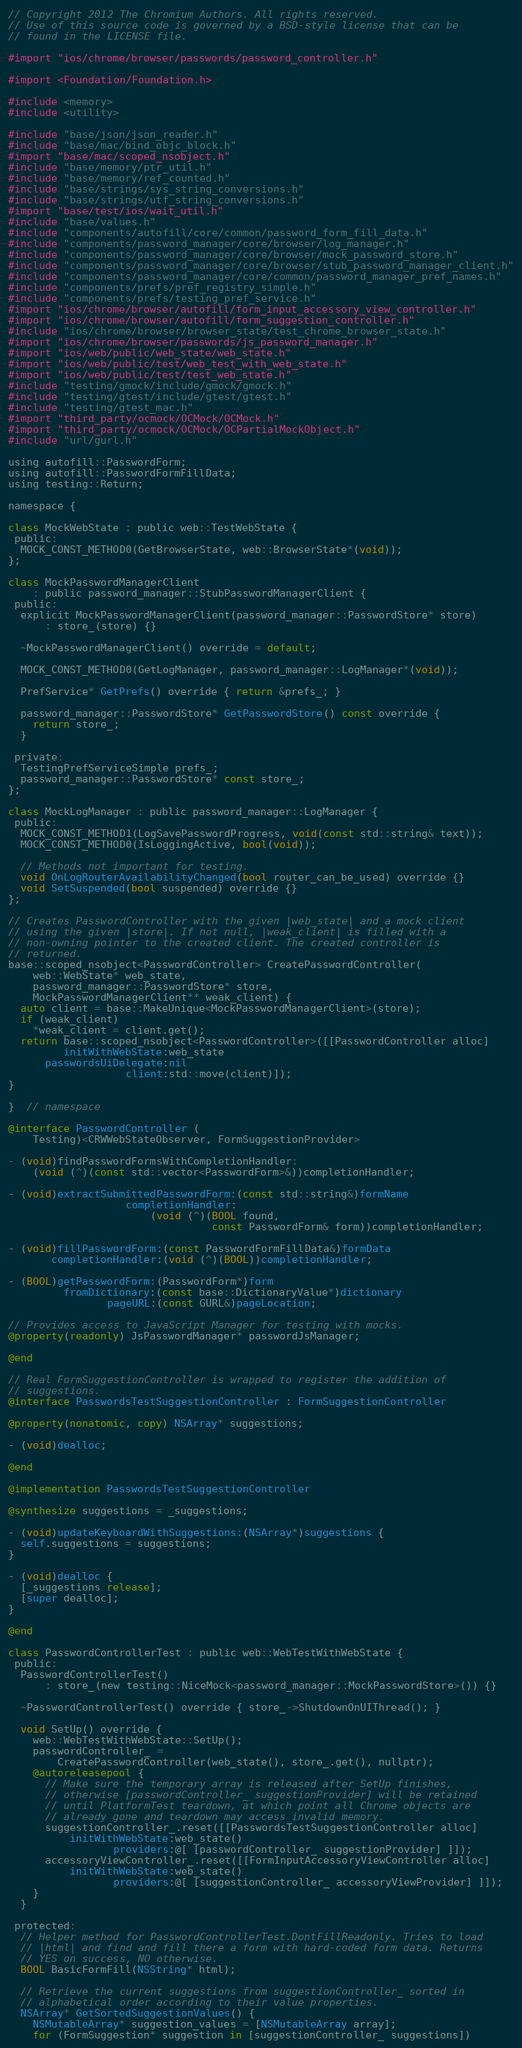Convert code to text. <code><loc_0><loc_0><loc_500><loc_500><_ObjectiveC_>// Copyright 2012 The Chromium Authors. All rights reserved.
// Use of this source code is governed by a BSD-style license that can be
// found in the LICENSE file.

#import "ios/chrome/browser/passwords/password_controller.h"

#import <Foundation/Foundation.h>

#include <memory>
#include <utility>

#include "base/json/json_reader.h"
#include "base/mac/bind_objc_block.h"
#import "base/mac/scoped_nsobject.h"
#include "base/memory/ptr_util.h"
#include "base/memory/ref_counted.h"
#include "base/strings/sys_string_conversions.h"
#include "base/strings/utf_string_conversions.h"
#import "base/test/ios/wait_util.h"
#include "base/values.h"
#include "components/autofill/core/common/password_form_fill_data.h"
#include "components/password_manager/core/browser/log_manager.h"
#include "components/password_manager/core/browser/mock_password_store.h"
#include "components/password_manager/core/browser/stub_password_manager_client.h"
#include "components/password_manager/core/common/password_manager_pref_names.h"
#include "components/prefs/pref_registry_simple.h"
#include "components/prefs/testing_pref_service.h"
#import "ios/chrome/browser/autofill/form_input_accessory_view_controller.h"
#import "ios/chrome/browser/autofill/form_suggestion_controller.h"
#include "ios/chrome/browser/browser_state/test_chrome_browser_state.h"
#import "ios/chrome/browser/passwords/js_password_manager.h"
#import "ios/web/public/web_state/web_state.h"
#import "ios/web/public/test/web_test_with_web_state.h"
#import "ios/web/public/test/test_web_state.h"
#include "testing/gmock/include/gmock/gmock.h"
#include "testing/gtest/include/gtest/gtest.h"
#include "testing/gtest_mac.h"
#import "third_party/ocmock/OCMock/OCMock.h"
#import "third_party/ocmock/OCMock/OCPartialMockObject.h"
#include "url/gurl.h"

using autofill::PasswordForm;
using autofill::PasswordFormFillData;
using testing::Return;

namespace {

class MockWebState : public web::TestWebState {
 public:
  MOCK_CONST_METHOD0(GetBrowserState, web::BrowserState*(void));
};

class MockPasswordManagerClient
    : public password_manager::StubPasswordManagerClient {
 public:
  explicit MockPasswordManagerClient(password_manager::PasswordStore* store)
      : store_(store) {}

  ~MockPasswordManagerClient() override = default;

  MOCK_CONST_METHOD0(GetLogManager, password_manager::LogManager*(void));

  PrefService* GetPrefs() override { return &prefs_; }

  password_manager::PasswordStore* GetPasswordStore() const override {
    return store_;
  }

 private:
  TestingPrefServiceSimple prefs_;
  password_manager::PasswordStore* const store_;
};

class MockLogManager : public password_manager::LogManager {
 public:
  MOCK_CONST_METHOD1(LogSavePasswordProgress, void(const std::string& text));
  MOCK_CONST_METHOD0(IsLoggingActive, bool(void));

  // Methods not important for testing.
  void OnLogRouterAvailabilityChanged(bool router_can_be_used) override {}
  void SetSuspended(bool suspended) override {}
};

// Creates PasswordController with the given |web_state| and a mock client
// using the given |store|. If not null, |weak_client| is filled with a
// non-owning pointer to the created client. The created controller is
// returned.
base::scoped_nsobject<PasswordController> CreatePasswordController(
    web::WebState* web_state,
    password_manager::PasswordStore* store,
    MockPasswordManagerClient** weak_client) {
  auto client = base::MakeUnique<MockPasswordManagerClient>(store);
  if (weak_client)
    *weak_client = client.get();
  return base::scoped_nsobject<PasswordController>([[PasswordController alloc]
         initWithWebState:web_state
      passwordsUiDelegate:nil
                   client:std::move(client)]);
}

}  // namespace

@interface PasswordController (
    Testing)<CRWWebStateObserver, FormSuggestionProvider>

- (void)findPasswordFormsWithCompletionHandler:
    (void (^)(const std::vector<PasswordForm>&))completionHandler;

- (void)extractSubmittedPasswordForm:(const std::string&)formName
                   completionHandler:
                       (void (^)(BOOL found,
                                 const PasswordForm& form))completionHandler;

- (void)fillPasswordForm:(const PasswordFormFillData&)formData
       completionHandler:(void (^)(BOOL))completionHandler;

- (BOOL)getPasswordForm:(PasswordForm*)form
         fromDictionary:(const base::DictionaryValue*)dictionary
                pageURL:(const GURL&)pageLocation;

// Provides access to JavaScript Manager for testing with mocks.
@property(readonly) JsPasswordManager* passwordJsManager;

@end

// Real FormSuggestionController is wrapped to register the addition of
// suggestions.
@interface PasswordsTestSuggestionController : FormSuggestionController

@property(nonatomic, copy) NSArray* suggestions;

- (void)dealloc;

@end

@implementation PasswordsTestSuggestionController

@synthesize suggestions = _suggestions;

- (void)updateKeyboardWithSuggestions:(NSArray*)suggestions {
  self.suggestions = suggestions;
}

- (void)dealloc {
  [_suggestions release];
  [super dealloc];
}

@end

class PasswordControllerTest : public web::WebTestWithWebState {
 public:
  PasswordControllerTest()
      : store_(new testing::NiceMock<password_manager::MockPasswordStore>()) {}

  ~PasswordControllerTest() override { store_->ShutdownOnUIThread(); }

  void SetUp() override {
    web::WebTestWithWebState::SetUp();
    passwordController_ =
        CreatePasswordController(web_state(), store_.get(), nullptr);
    @autoreleasepool {
      // Make sure the temporary array is released after SetUp finishes,
      // otherwise [passwordController_ suggestionProvider] will be retained
      // until PlatformTest teardown, at which point all Chrome objects are
      // already gone and teardown may access invalid memory.
      suggestionController_.reset([[PasswordsTestSuggestionController alloc]
          initWithWebState:web_state()
                 providers:@[ [passwordController_ suggestionProvider] ]]);
      accessoryViewController_.reset([[FormInputAccessoryViewController alloc]
          initWithWebState:web_state()
                 providers:@[ [suggestionController_ accessoryViewProvider] ]]);
    }
  }

 protected:
  // Helper method for PasswordControllerTest.DontFillReadonly. Tries to load
  // |html| and find and fill there a form with hard-coded form data. Returns
  // YES on success, NO otherwise.
  BOOL BasicFormFill(NSString* html);

  // Retrieve the current suggestions from suggestionController_ sorted in
  // alphabetical order according to their value properties.
  NSArray* GetSortedSuggestionValues() {
    NSMutableArray* suggestion_values = [NSMutableArray array];
    for (FormSuggestion* suggestion in [suggestionController_ suggestions])</code> 